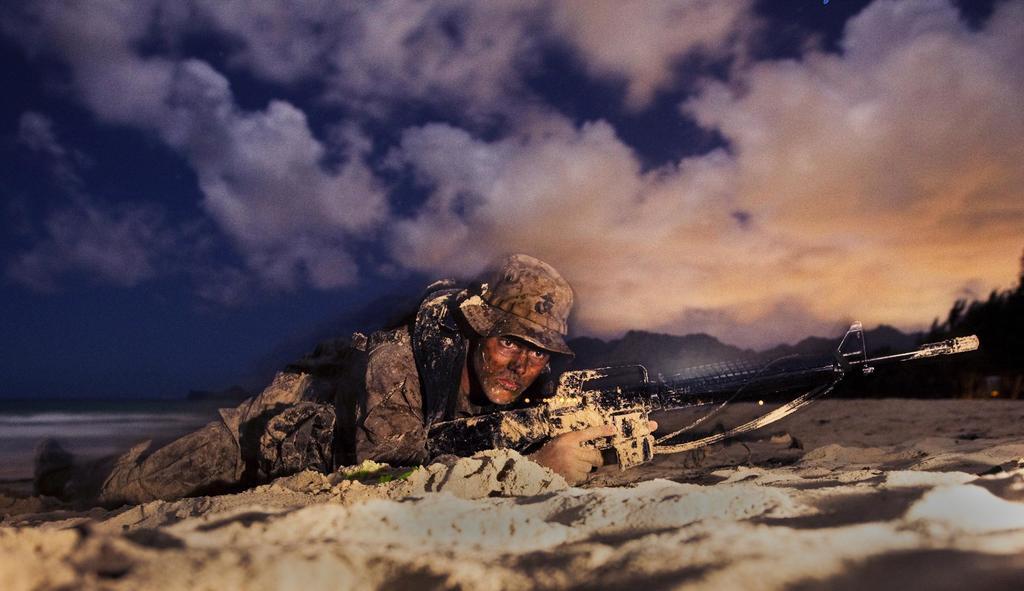In one or two sentences, can you explain what this image depicts? In this image there is a soil ground on the bottom of this image and there is one person is lying on this ground and holding a gun in middle of this image. There is a cloudy sky on the top of this image and there are some trees on the right side of this image. 